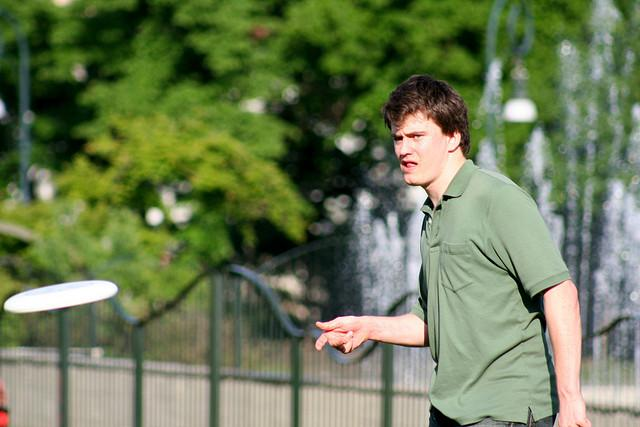The color of the shirt matches the color of what?

Choices:
A) sky
B) peaches
C) elephants
D) money money 